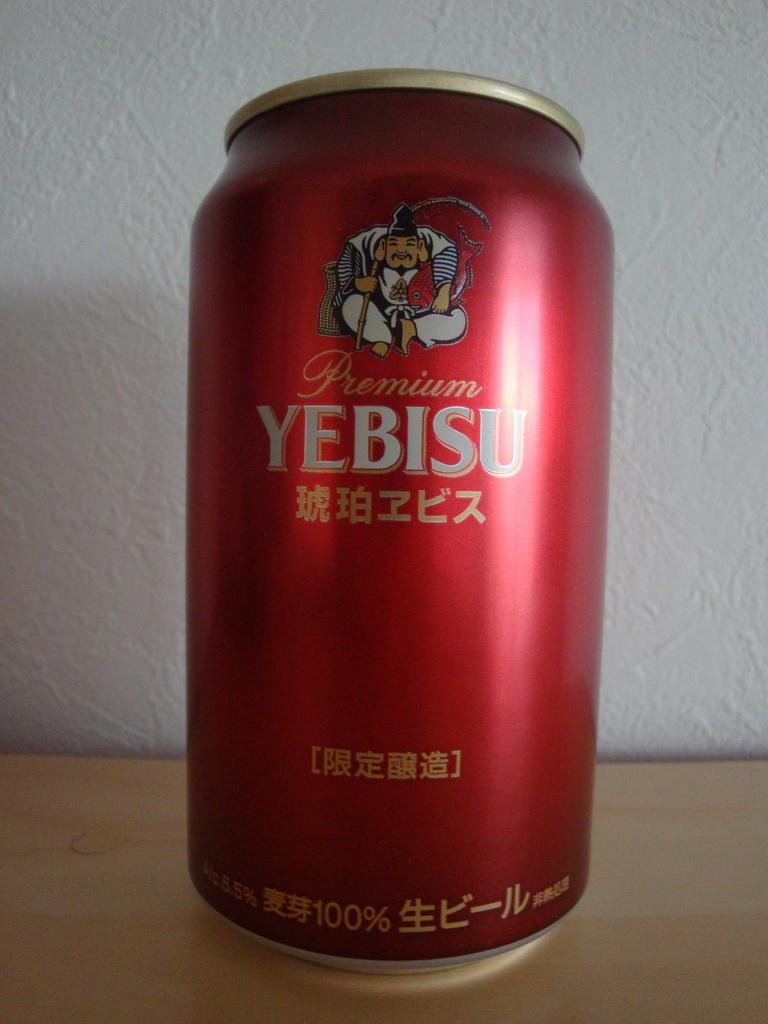What's the name of this drink?
Offer a very short reply. Yebisu. How much alcohol percentage?
Offer a terse response. 5.5. 